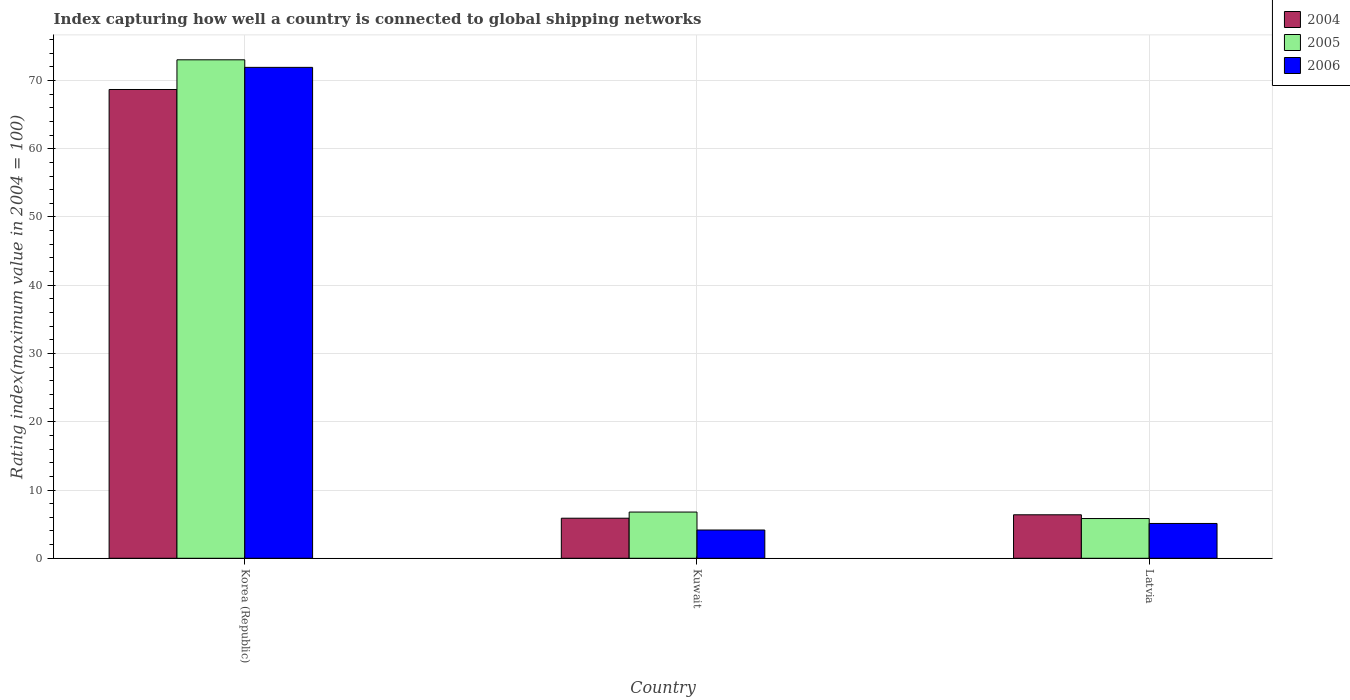How many groups of bars are there?
Provide a short and direct response. 3. How many bars are there on the 2nd tick from the right?
Offer a terse response. 3. What is the label of the 1st group of bars from the left?
Give a very brief answer. Korea (Republic). What is the rating index in 2005 in Kuwait?
Ensure brevity in your answer.  6.77. Across all countries, what is the maximum rating index in 2004?
Keep it short and to the point. 68.68. Across all countries, what is the minimum rating index in 2006?
Offer a terse response. 4.14. In which country was the rating index in 2006 minimum?
Your response must be concise. Kuwait. What is the total rating index in 2006 in the graph?
Offer a terse response. 81.16. What is the difference between the rating index in 2005 in Korea (Republic) and that in Kuwait?
Provide a short and direct response. 66.26. What is the difference between the rating index in 2005 in Latvia and the rating index in 2006 in Kuwait?
Offer a terse response. 1.68. What is the average rating index in 2006 per country?
Ensure brevity in your answer.  27.05. What is the difference between the rating index of/in 2006 and rating index of/in 2005 in Kuwait?
Offer a terse response. -2.63. What is the ratio of the rating index in 2004 in Kuwait to that in Latvia?
Give a very brief answer. 0.92. What is the difference between the highest and the second highest rating index in 2004?
Give a very brief answer. 62.81. What is the difference between the highest and the lowest rating index in 2006?
Keep it short and to the point. 67.78. In how many countries, is the rating index in 2005 greater than the average rating index in 2005 taken over all countries?
Provide a succinct answer. 1. What does the 1st bar from the left in Kuwait represents?
Keep it short and to the point. 2004. Are all the bars in the graph horizontal?
Your answer should be very brief. No. How many legend labels are there?
Your answer should be very brief. 3. What is the title of the graph?
Keep it short and to the point. Index capturing how well a country is connected to global shipping networks. What is the label or title of the Y-axis?
Provide a succinct answer. Rating index(maximum value in 2004 = 100). What is the Rating index(maximum value in 2004 = 100) of 2004 in Korea (Republic)?
Your answer should be very brief. 68.68. What is the Rating index(maximum value in 2004 = 100) in 2005 in Korea (Republic)?
Give a very brief answer. 73.03. What is the Rating index(maximum value in 2004 = 100) of 2006 in Korea (Republic)?
Provide a succinct answer. 71.92. What is the Rating index(maximum value in 2004 = 100) in 2004 in Kuwait?
Provide a succinct answer. 5.87. What is the Rating index(maximum value in 2004 = 100) of 2005 in Kuwait?
Your answer should be compact. 6.77. What is the Rating index(maximum value in 2004 = 100) of 2006 in Kuwait?
Your answer should be compact. 4.14. What is the Rating index(maximum value in 2004 = 100) of 2004 in Latvia?
Your answer should be very brief. 6.37. What is the Rating index(maximum value in 2004 = 100) of 2005 in Latvia?
Your answer should be very brief. 5.82. What is the Rating index(maximum value in 2004 = 100) in 2006 in Latvia?
Make the answer very short. 5.1. Across all countries, what is the maximum Rating index(maximum value in 2004 = 100) in 2004?
Your answer should be very brief. 68.68. Across all countries, what is the maximum Rating index(maximum value in 2004 = 100) in 2005?
Offer a terse response. 73.03. Across all countries, what is the maximum Rating index(maximum value in 2004 = 100) of 2006?
Ensure brevity in your answer.  71.92. Across all countries, what is the minimum Rating index(maximum value in 2004 = 100) of 2004?
Ensure brevity in your answer.  5.87. Across all countries, what is the minimum Rating index(maximum value in 2004 = 100) in 2005?
Your response must be concise. 5.82. Across all countries, what is the minimum Rating index(maximum value in 2004 = 100) in 2006?
Give a very brief answer. 4.14. What is the total Rating index(maximum value in 2004 = 100) in 2004 in the graph?
Give a very brief answer. 80.92. What is the total Rating index(maximum value in 2004 = 100) of 2005 in the graph?
Keep it short and to the point. 85.62. What is the total Rating index(maximum value in 2004 = 100) in 2006 in the graph?
Ensure brevity in your answer.  81.16. What is the difference between the Rating index(maximum value in 2004 = 100) in 2004 in Korea (Republic) and that in Kuwait?
Ensure brevity in your answer.  62.81. What is the difference between the Rating index(maximum value in 2004 = 100) of 2005 in Korea (Republic) and that in Kuwait?
Your answer should be compact. 66.26. What is the difference between the Rating index(maximum value in 2004 = 100) of 2006 in Korea (Republic) and that in Kuwait?
Ensure brevity in your answer.  67.78. What is the difference between the Rating index(maximum value in 2004 = 100) of 2004 in Korea (Republic) and that in Latvia?
Provide a short and direct response. 62.31. What is the difference between the Rating index(maximum value in 2004 = 100) of 2005 in Korea (Republic) and that in Latvia?
Ensure brevity in your answer.  67.21. What is the difference between the Rating index(maximum value in 2004 = 100) in 2006 in Korea (Republic) and that in Latvia?
Keep it short and to the point. 66.82. What is the difference between the Rating index(maximum value in 2004 = 100) in 2006 in Kuwait and that in Latvia?
Your answer should be compact. -0.96. What is the difference between the Rating index(maximum value in 2004 = 100) of 2004 in Korea (Republic) and the Rating index(maximum value in 2004 = 100) of 2005 in Kuwait?
Offer a terse response. 61.91. What is the difference between the Rating index(maximum value in 2004 = 100) in 2004 in Korea (Republic) and the Rating index(maximum value in 2004 = 100) in 2006 in Kuwait?
Your answer should be very brief. 64.54. What is the difference between the Rating index(maximum value in 2004 = 100) of 2005 in Korea (Republic) and the Rating index(maximum value in 2004 = 100) of 2006 in Kuwait?
Ensure brevity in your answer.  68.89. What is the difference between the Rating index(maximum value in 2004 = 100) of 2004 in Korea (Republic) and the Rating index(maximum value in 2004 = 100) of 2005 in Latvia?
Offer a very short reply. 62.86. What is the difference between the Rating index(maximum value in 2004 = 100) in 2004 in Korea (Republic) and the Rating index(maximum value in 2004 = 100) in 2006 in Latvia?
Your answer should be compact. 63.58. What is the difference between the Rating index(maximum value in 2004 = 100) in 2005 in Korea (Republic) and the Rating index(maximum value in 2004 = 100) in 2006 in Latvia?
Make the answer very short. 67.93. What is the difference between the Rating index(maximum value in 2004 = 100) of 2004 in Kuwait and the Rating index(maximum value in 2004 = 100) of 2005 in Latvia?
Make the answer very short. 0.05. What is the difference between the Rating index(maximum value in 2004 = 100) of 2004 in Kuwait and the Rating index(maximum value in 2004 = 100) of 2006 in Latvia?
Provide a short and direct response. 0.77. What is the difference between the Rating index(maximum value in 2004 = 100) of 2005 in Kuwait and the Rating index(maximum value in 2004 = 100) of 2006 in Latvia?
Your answer should be very brief. 1.67. What is the average Rating index(maximum value in 2004 = 100) in 2004 per country?
Your answer should be compact. 26.97. What is the average Rating index(maximum value in 2004 = 100) in 2005 per country?
Offer a very short reply. 28.54. What is the average Rating index(maximum value in 2004 = 100) of 2006 per country?
Give a very brief answer. 27.05. What is the difference between the Rating index(maximum value in 2004 = 100) of 2004 and Rating index(maximum value in 2004 = 100) of 2005 in Korea (Republic)?
Provide a short and direct response. -4.35. What is the difference between the Rating index(maximum value in 2004 = 100) in 2004 and Rating index(maximum value in 2004 = 100) in 2006 in Korea (Republic)?
Provide a succinct answer. -3.24. What is the difference between the Rating index(maximum value in 2004 = 100) of 2005 and Rating index(maximum value in 2004 = 100) of 2006 in Korea (Republic)?
Your answer should be compact. 1.11. What is the difference between the Rating index(maximum value in 2004 = 100) in 2004 and Rating index(maximum value in 2004 = 100) in 2006 in Kuwait?
Offer a very short reply. 1.73. What is the difference between the Rating index(maximum value in 2004 = 100) of 2005 and Rating index(maximum value in 2004 = 100) of 2006 in Kuwait?
Make the answer very short. 2.63. What is the difference between the Rating index(maximum value in 2004 = 100) of 2004 and Rating index(maximum value in 2004 = 100) of 2005 in Latvia?
Offer a terse response. 0.55. What is the difference between the Rating index(maximum value in 2004 = 100) of 2004 and Rating index(maximum value in 2004 = 100) of 2006 in Latvia?
Offer a terse response. 1.27. What is the difference between the Rating index(maximum value in 2004 = 100) in 2005 and Rating index(maximum value in 2004 = 100) in 2006 in Latvia?
Give a very brief answer. 0.72. What is the ratio of the Rating index(maximum value in 2004 = 100) of 2004 in Korea (Republic) to that in Kuwait?
Offer a very short reply. 11.7. What is the ratio of the Rating index(maximum value in 2004 = 100) of 2005 in Korea (Republic) to that in Kuwait?
Keep it short and to the point. 10.79. What is the ratio of the Rating index(maximum value in 2004 = 100) of 2006 in Korea (Republic) to that in Kuwait?
Your answer should be compact. 17.37. What is the ratio of the Rating index(maximum value in 2004 = 100) in 2004 in Korea (Republic) to that in Latvia?
Provide a short and direct response. 10.78. What is the ratio of the Rating index(maximum value in 2004 = 100) in 2005 in Korea (Republic) to that in Latvia?
Offer a very short reply. 12.55. What is the ratio of the Rating index(maximum value in 2004 = 100) in 2006 in Korea (Republic) to that in Latvia?
Make the answer very short. 14.1. What is the ratio of the Rating index(maximum value in 2004 = 100) of 2004 in Kuwait to that in Latvia?
Offer a terse response. 0.92. What is the ratio of the Rating index(maximum value in 2004 = 100) in 2005 in Kuwait to that in Latvia?
Provide a short and direct response. 1.16. What is the ratio of the Rating index(maximum value in 2004 = 100) in 2006 in Kuwait to that in Latvia?
Keep it short and to the point. 0.81. What is the difference between the highest and the second highest Rating index(maximum value in 2004 = 100) in 2004?
Provide a short and direct response. 62.31. What is the difference between the highest and the second highest Rating index(maximum value in 2004 = 100) of 2005?
Make the answer very short. 66.26. What is the difference between the highest and the second highest Rating index(maximum value in 2004 = 100) of 2006?
Your response must be concise. 66.82. What is the difference between the highest and the lowest Rating index(maximum value in 2004 = 100) of 2004?
Provide a short and direct response. 62.81. What is the difference between the highest and the lowest Rating index(maximum value in 2004 = 100) in 2005?
Give a very brief answer. 67.21. What is the difference between the highest and the lowest Rating index(maximum value in 2004 = 100) of 2006?
Make the answer very short. 67.78. 